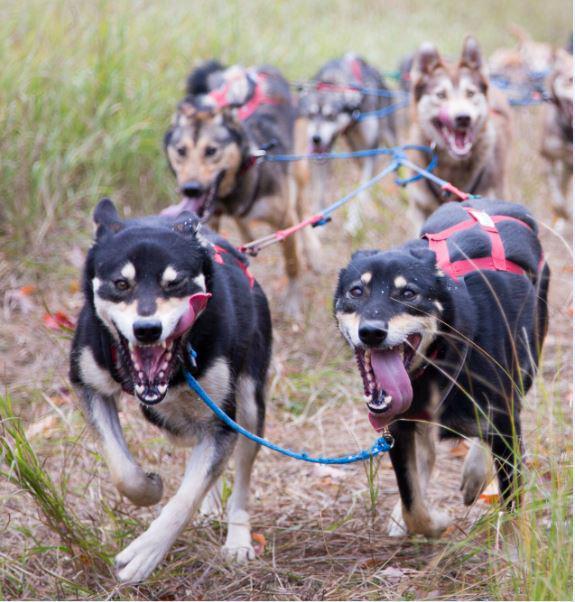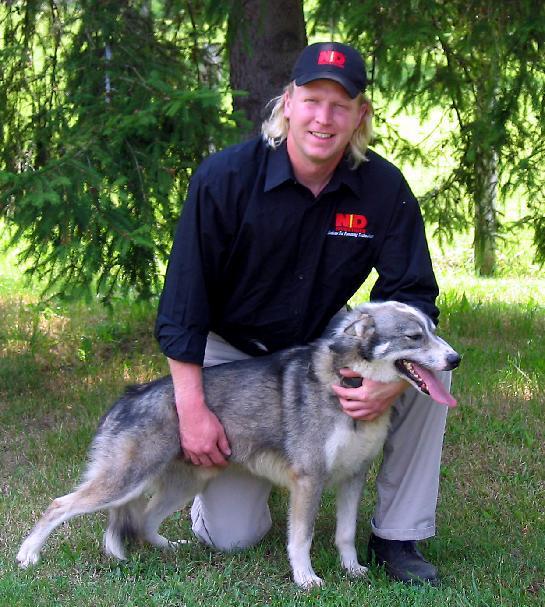The first image is the image on the left, the second image is the image on the right. Analyze the images presented: Is the assertion "There is exactly one dog in the image on the right." valid? Answer yes or no. Yes. The first image is the image on the left, the second image is the image on the right. Evaluate the accuracy of this statement regarding the images: "A person is being pulled by a team of dogs in one image.". Is it true? Answer yes or no. No. 